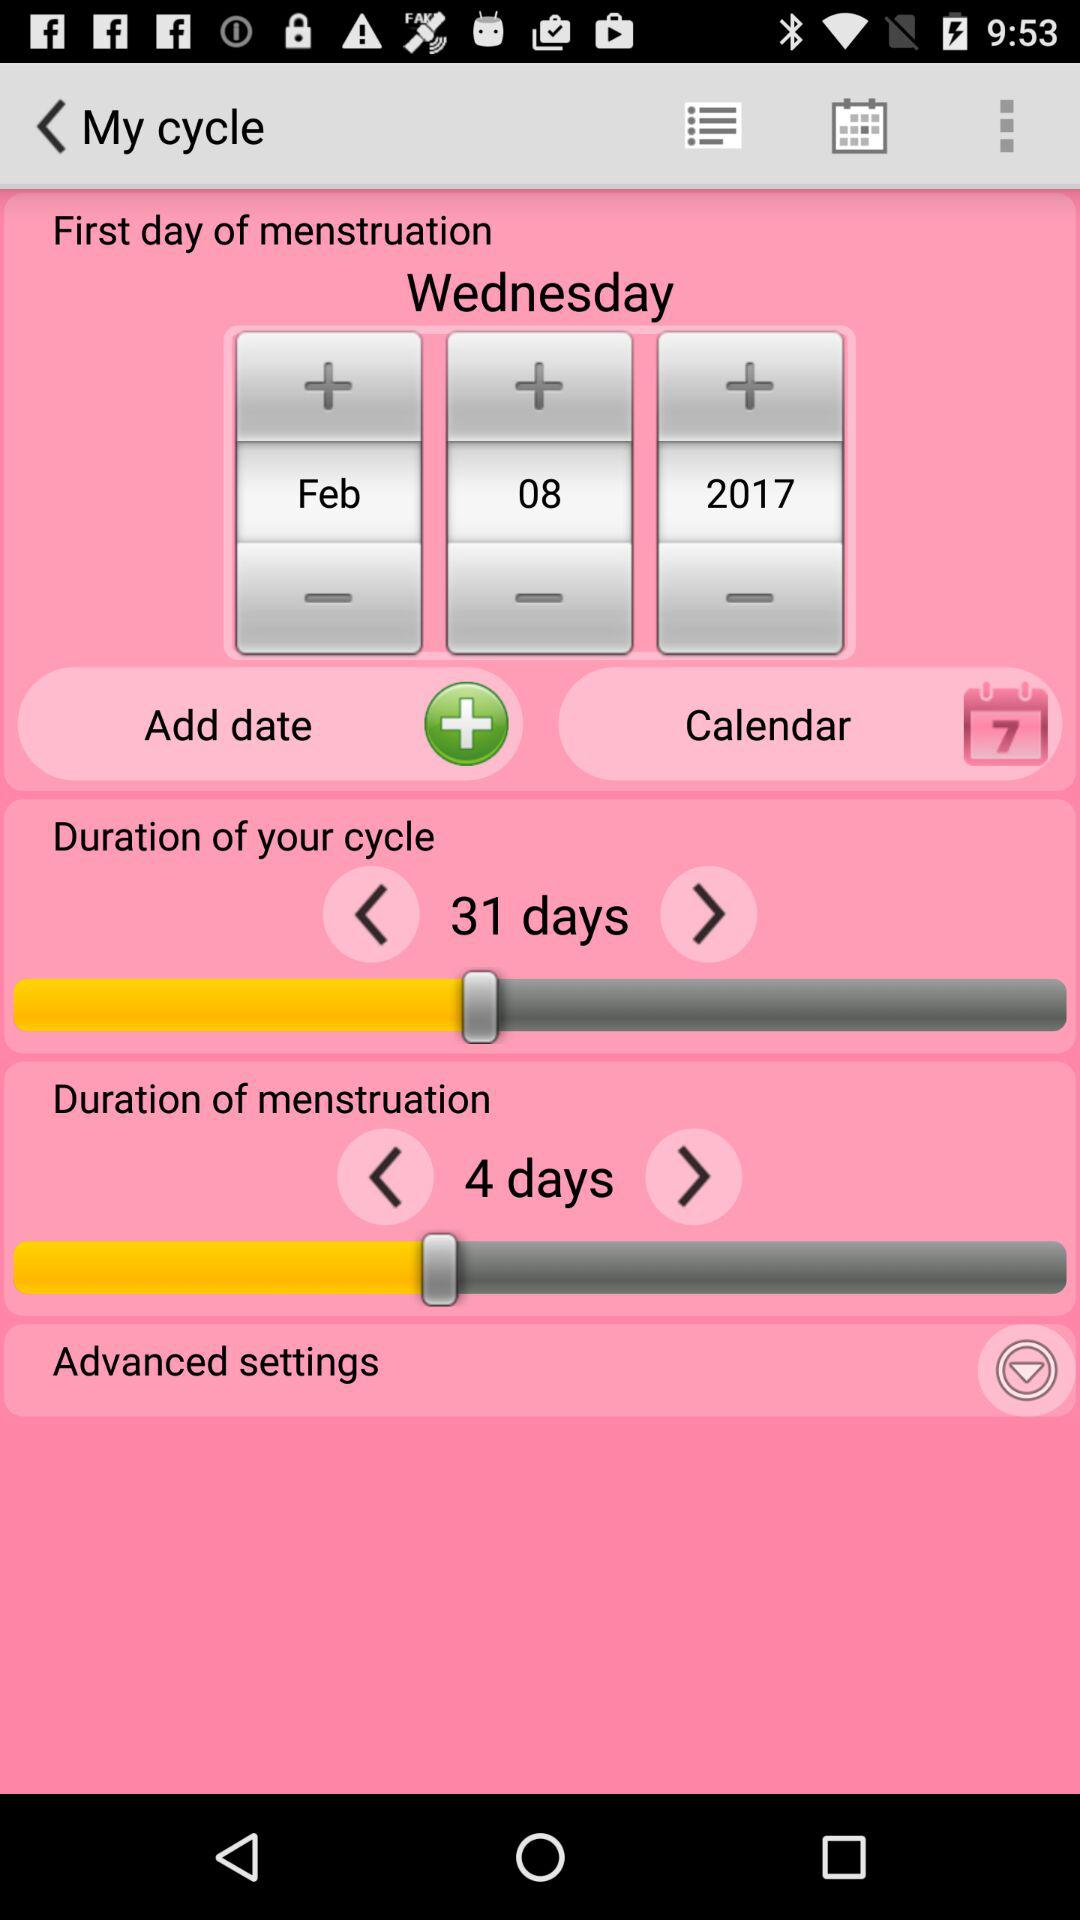How long is the cycle duration? The cycle duration is 31 days. 